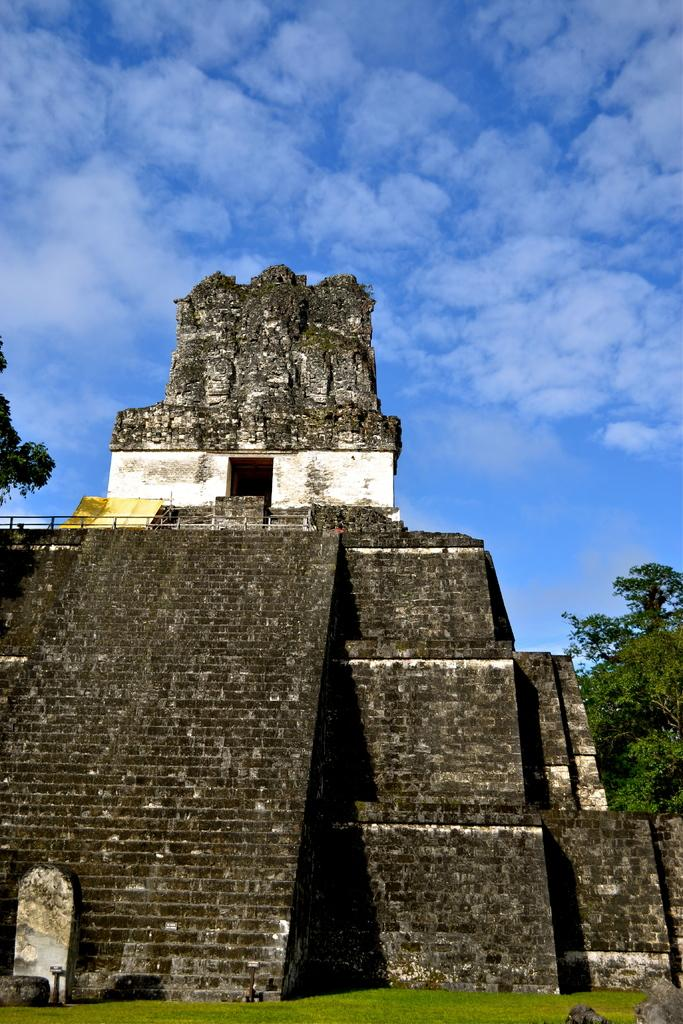What is the main subject of the picture? There is a monument in the picture. What can be seen on the right side of the picture? There is a tree on the right side of the picture. What is visible in the sky in the picture? There are clouds in the sky. Where is the mark on the table in the picture? There is no table or mark present in the picture; it only features a monument, a tree, and clouds in the sky. 